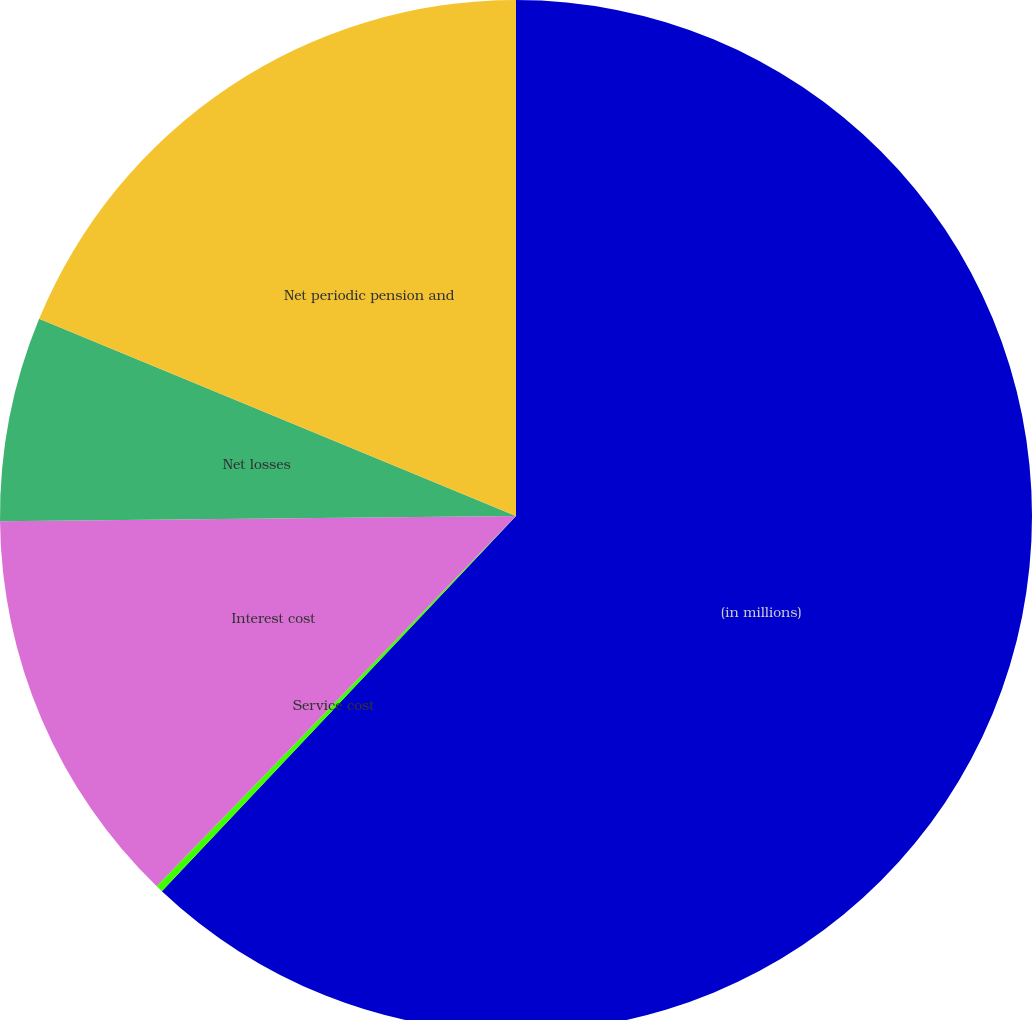Convert chart to OTSL. <chart><loc_0><loc_0><loc_500><loc_500><pie_chart><fcel>(in millions)<fcel>Service cost<fcel>Interest cost<fcel>Net losses<fcel>Net periodic pension and<nl><fcel>62.04%<fcel>0.22%<fcel>12.58%<fcel>6.4%<fcel>18.76%<nl></chart> 